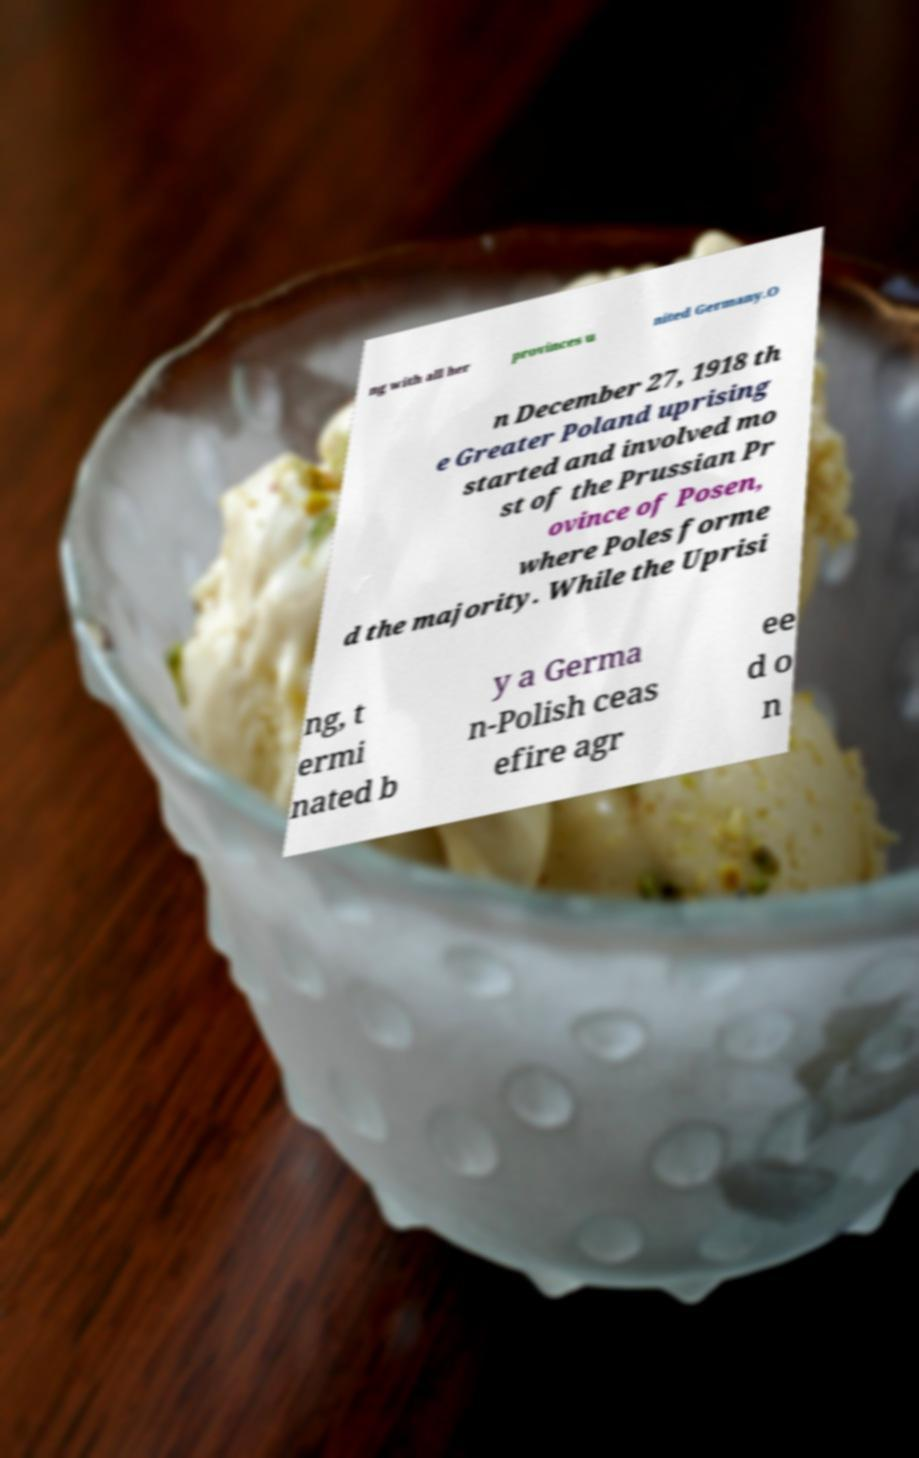Could you extract and type out the text from this image? ng with all her provinces u nited Germany.O n December 27, 1918 th e Greater Poland uprising started and involved mo st of the Prussian Pr ovince of Posen, where Poles forme d the majority. While the Uprisi ng, t ermi nated b y a Germa n-Polish ceas efire agr ee d o n 